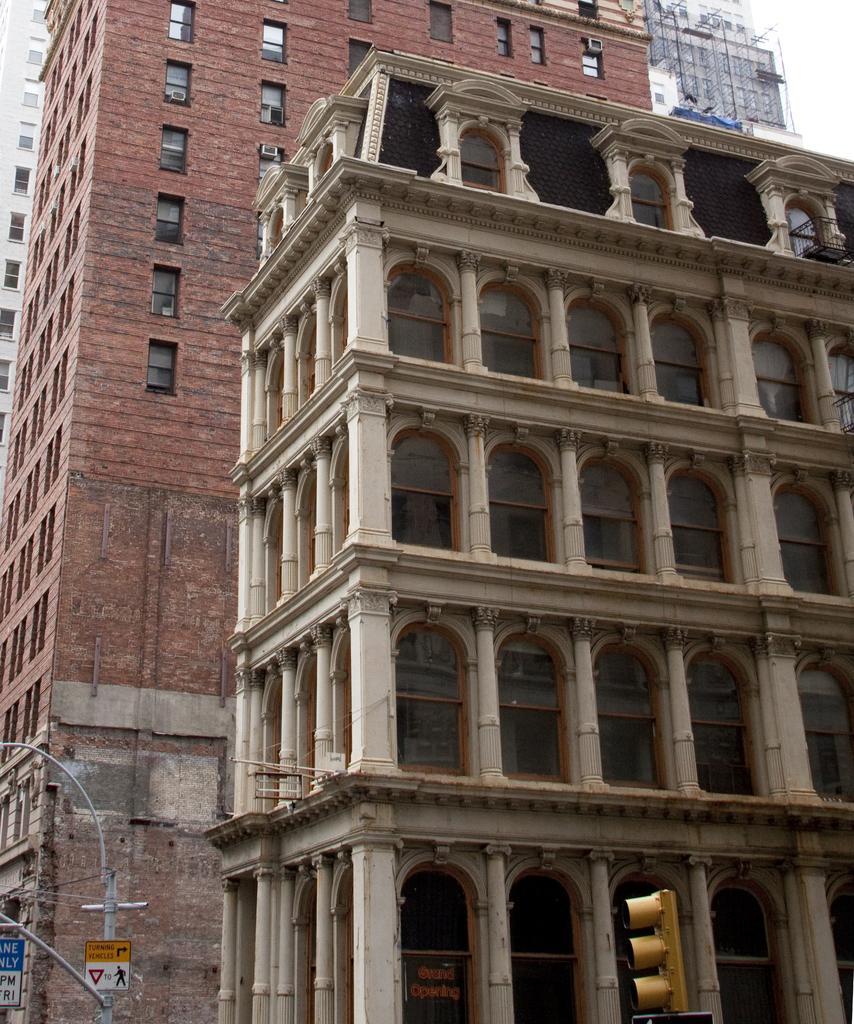Could you give a brief overview of what you see in this image? Here, we can see some buildings, at the left side there is a pole and there are some sign boards. 